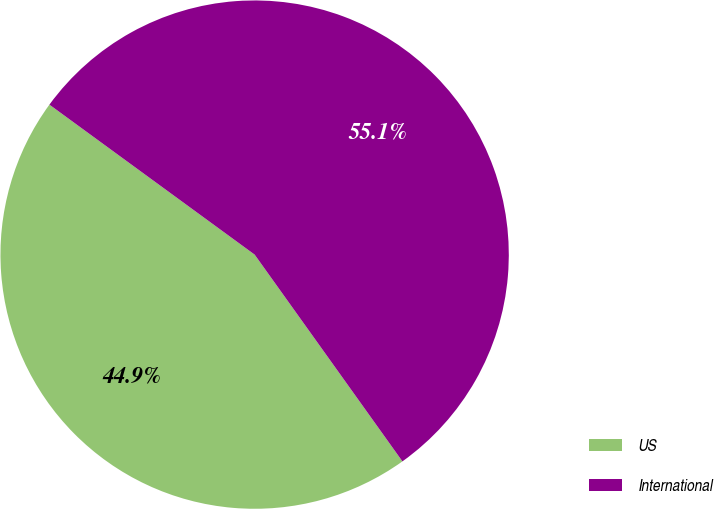Convert chart. <chart><loc_0><loc_0><loc_500><loc_500><pie_chart><fcel>US<fcel>International<nl><fcel>44.92%<fcel>55.08%<nl></chart> 